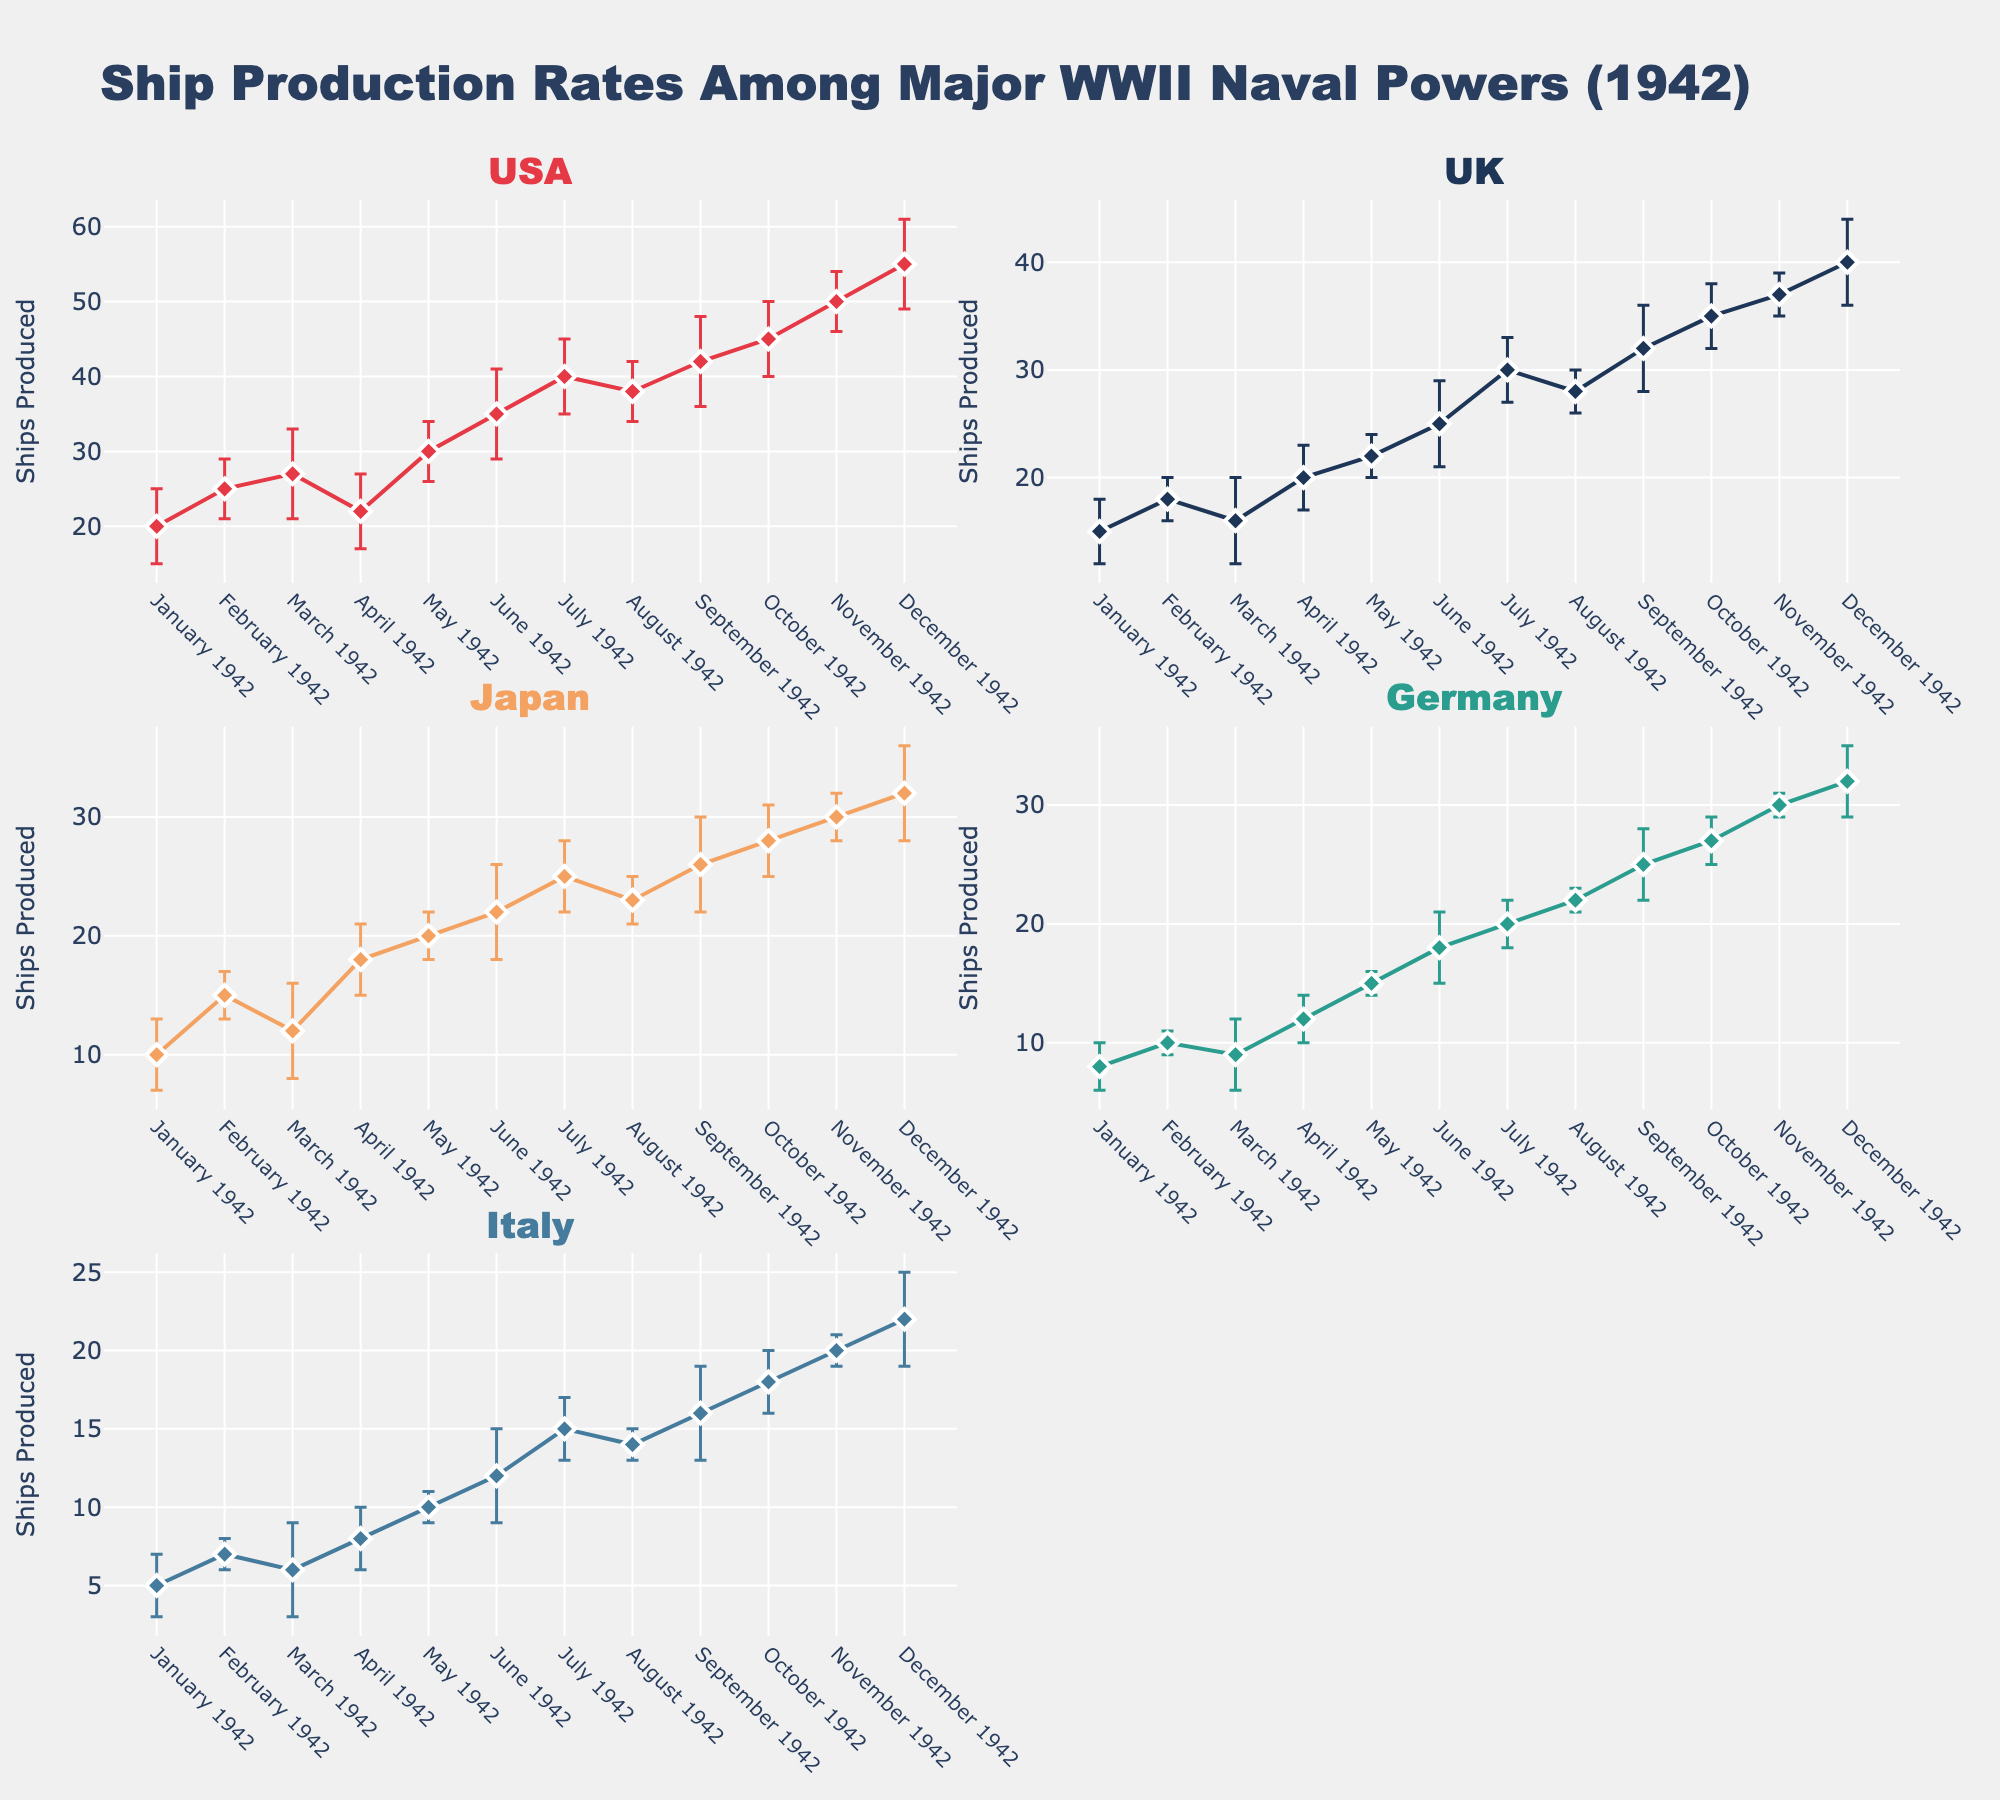what is the title of the figure? The title of the figure is usually displayed at the top and summarizes the content. Here, the title indicates the subject of the figure.
Answer: Ship Production Rates Among Major WWII Naval Powers (1942) How many subplots are there in the figure? By counting the distinct plot areas within the figure, you can identify the total number of subplots. Each subplot covers production data for a different country.
Answer: 5 Which country has the highest variability in ship production in July 1942? Variability is indicated by the length of the error bars. By comparing the error bars for each country in July, the country with the longest error bar has the highest variability.
Answer: USA What was the trend in ship production for the USA over the year 1942? By observing the pattern or slope of the line, one can describe the general trend. Here, you should look at the overall direction from January to December.
Answer: Increasing Which country had the lowest production rate in January 1942? Examine the data point heights in January 1942 for each country to determine which has the smallest value.
Answer: Italy Between which months did the UK see the largest increase in ship production? Look at the changes in the UK data points to find the pair of consecutive months where the difference between production values is the greatest.
Answer: June to July 1942 On average, how many ships did Japan produce each month in 1942? Summing Japan's monthly production values and dividing by the number of months (12) will give the average.
Answer: (10+15+12+18+20+22+25+23+26+28+30+32)/12 = 22.08 -> 22 ships per month Which two countries had the closest production rates in December 1942? Compare December's production values for each country and find the pair with the smallest difference.
Answer: Germany and Japan (Both 32) How many months had the UK produced more ships than Japan? For each month, compare the production values of the UK and Japan and count how many times the UK's value is higher.
Answer: 8 months (January, March, April, May, July, September, October, December) What is the largest error bar for Germany across all months in 1942, and in which month does this occur? Identify the month and the corresponding error bar for Germany that appears the longest.
Answer: December 1942, 3 ships 